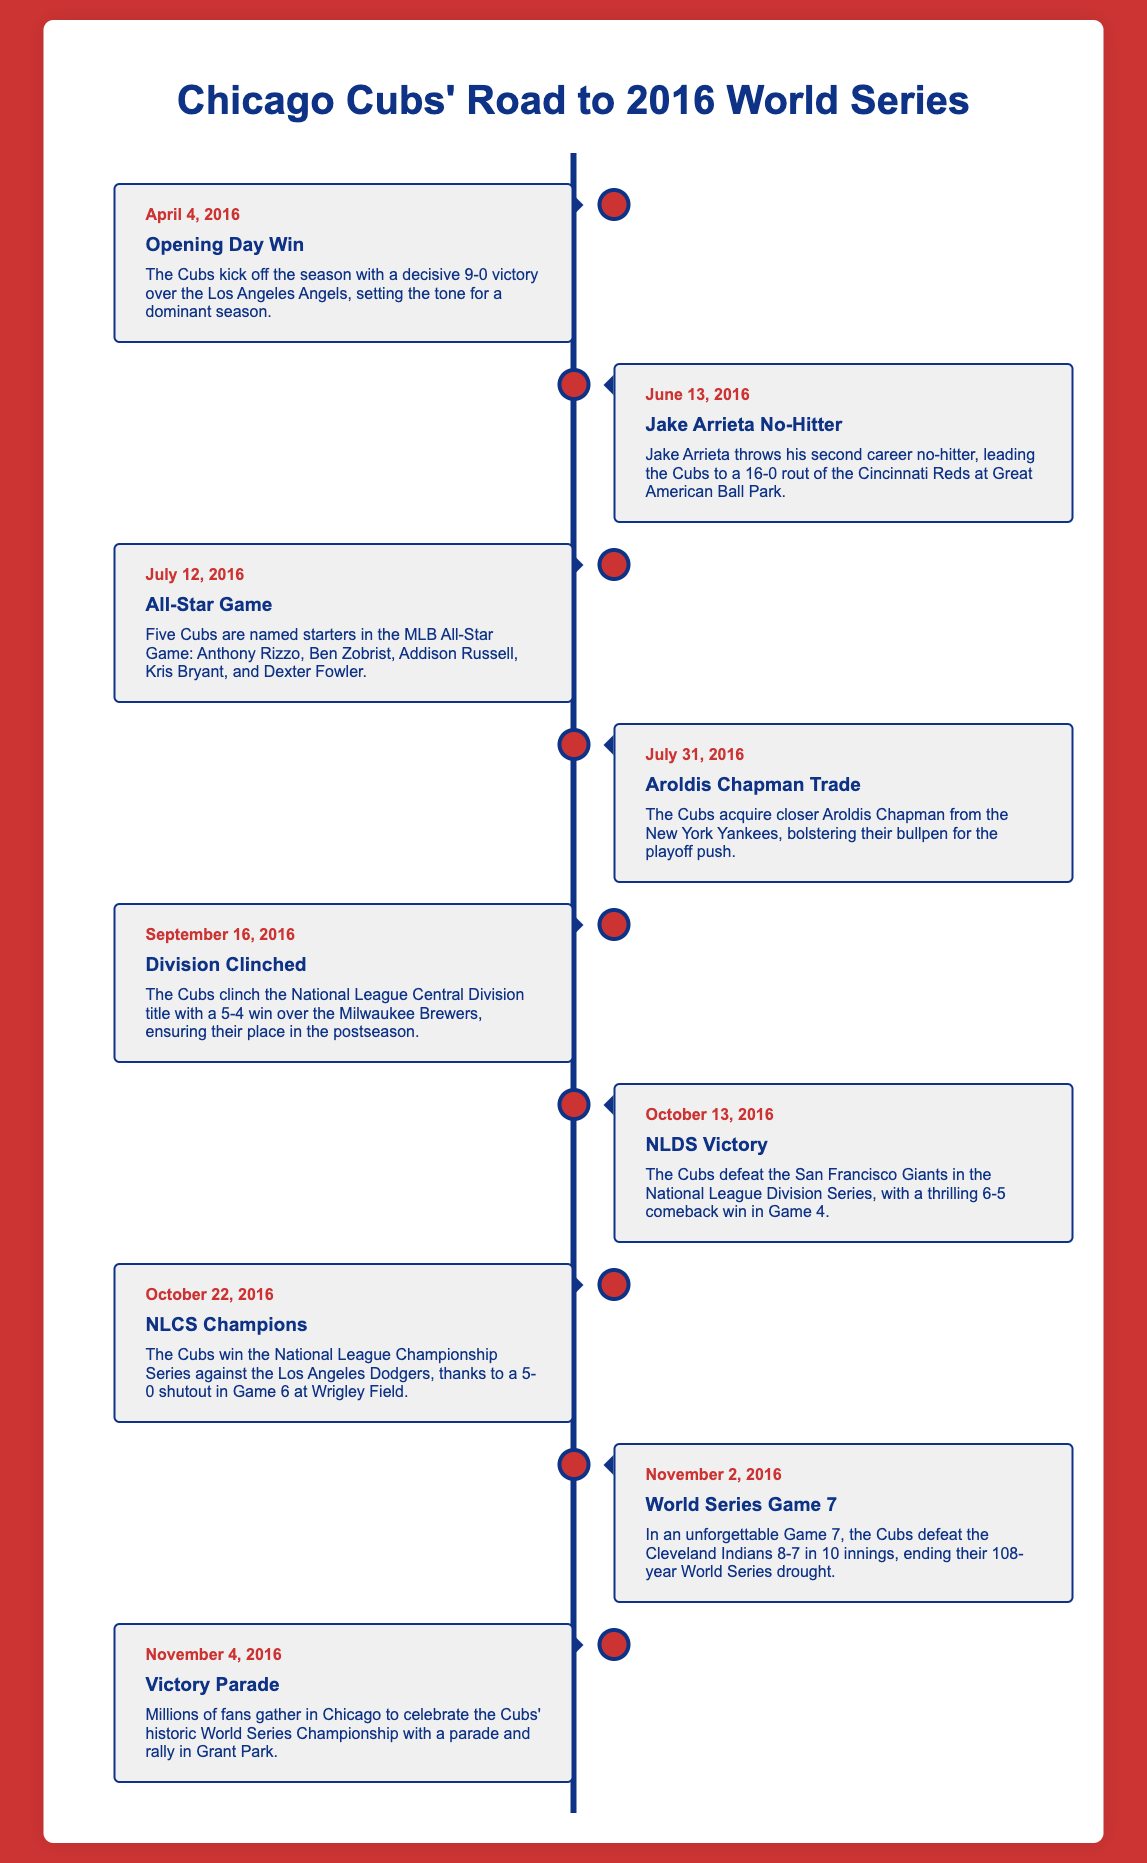What date did the Cubs open the season? The Cubs kicked off the season on April 4, 2016, as mentioned in the timeline.
Answer: April 4, 2016 How many All-Stars did the Cubs have in the All-Star Game? The timeline specifies that five Cubs were named starters in the MLB All-Star Game.
Answer: Five What was the score of the Cubs' victory over the Los Angeles Angels on Opening Day? The details indicate that the Cubs won the game with a score of 9-0.
Answer: 9-0 Who did the Cubs face in the NLDS? The timeline notes that the Cubs defeated the San Francisco Giants in the National League Division Series.
Answer: San Francisco Giants What significant event took place on November 2, 2016? The timeline describes the Cubs defeating the Cleveland Indians in Game 7 of the World Series.
Answer: Game 7 of the World Series What did the Cubs achieve on September 16, 2016? The event details state that the Cubs clinched the National League Central Division title with a victory over the Brewers.
Answer: Division title How did the Cubs perform in the NLCS? The timeline indicates that the Cubs won the National League Championship Series against the Los Angeles Dodgers.
Answer: Won What happened on November 4, 2016? Fans celebrated the Cubs' victory with a parade and rally in Grant Park, as stated in the document.
Answer: Victory Parade 